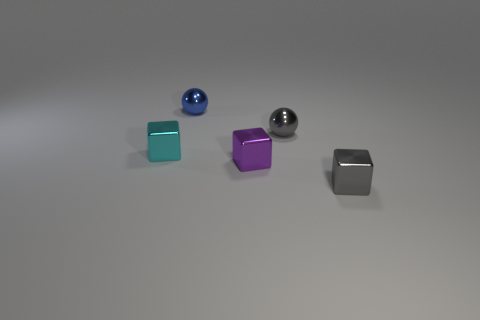Subtract all gray metal cubes. How many cubes are left? 2 Add 3 large cyan rubber balls. How many objects exist? 8 Subtract all gray blocks. How many blocks are left? 2 Subtract all spheres. How many objects are left? 3 Subtract all gray shiny cubes. Subtract all spheres. How many objects are left? 2 Add 2 small gray metal spheres. How many small gray metal spheres are left? 3 Add 3 metallic cubes. How many metallic cubes exist? 6 Subtract 0 brown balls. How many objects are left? 5 Subtract 1 spheres. How many spheres are left? 1 Subtract all gray balls. Subtract all yellow blocks. How many balls are left? 1 